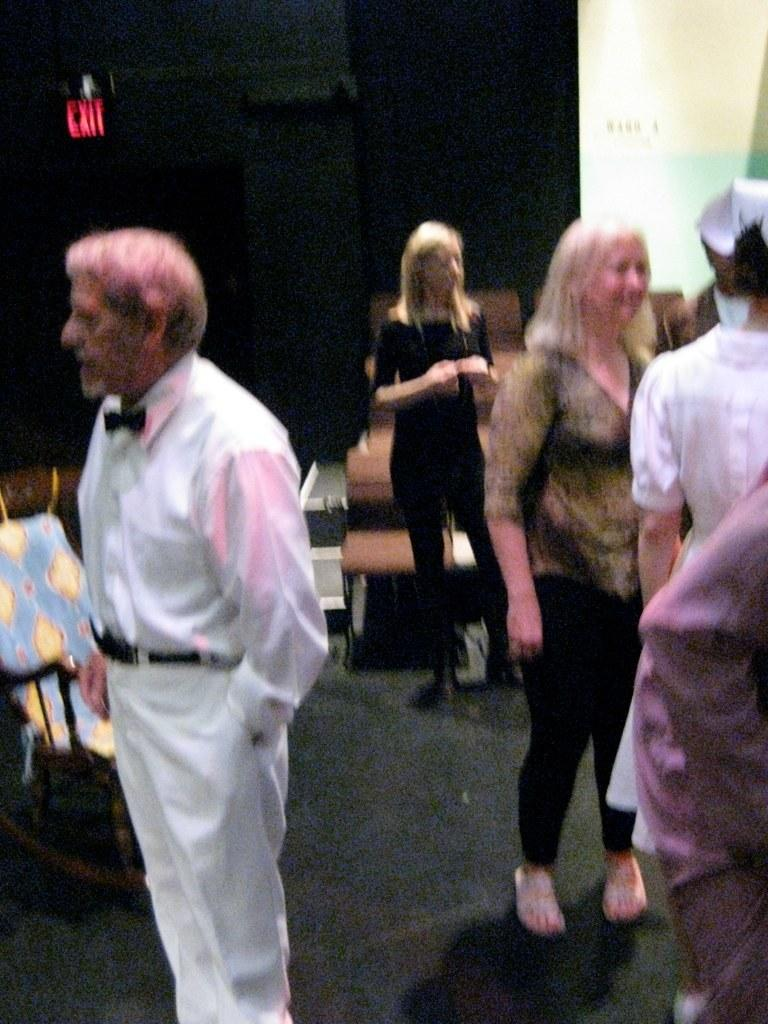How many people are in the image? There is a group of people in the image. What are the people doing in the image? The people are standing on the floor. What furniture can be seen in the image? There are chairs in the image. What type of object is present with written information? There is a signboard in the image. What type of structure is visible in the image? There is a wall in the image. What type of wool is being used to play the drum in the image? There is no wool or drum present in the image. What type of competition is taking place in the image? There is no competition present in the image. 